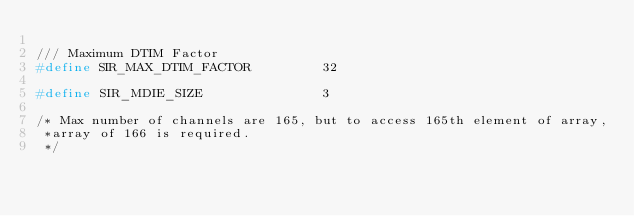Convert code to text. <code><loc_0><loc_0><loc_500><loc_500><_C_>
/// Maximum DTIM Factor
#define SIR_MAX_DTIM_FACTOR         32

#define SIR_MDIE_SIZE               3

/* Max number of channels are 165, but to access 165th element of array,
 *array of 166 is required.
 */</code> 